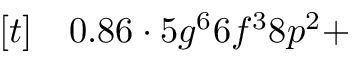<formula> <loc_0><loc_0><loc_500><loc_500>\begin{array} { r l } { [ t ] } & 0 . 8 6 \cdot 5 g ^ { 6 } 6 f ^ { 3 } 8 p ^ { 2 } + } \end{array}</formula> 